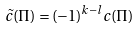Convert formula to latex. <formula><loc_0><loc_0><loc_500><loc_500>\tilde { c } ( \Pi ) = ( - 1 ) ^ { k - l } c ( \Pi )</formula> 